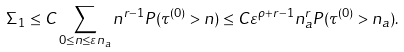Convert formula to latex. <formula><loc_0><loc_0><loc_500><loc_500>\Sigma _ { 1 } \leq C \sum _ { 0 \leq n \leq \varepsilon n _ { a } } n ^ { r - 1 } P ( \tau ^ { ( 0 ) } > n ) \leq C \varepsilon ^ { \rho + r - 1 } n _ { a } ^ { r } P ( \tau ^ { ( 0 ) } > n _ { a } ) .</formula> 